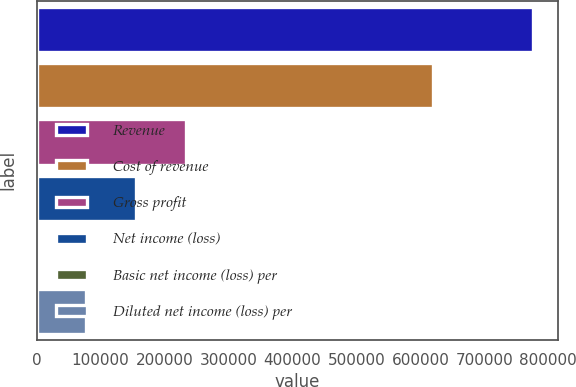<chart> <loc_0><loc_0><loc_500><loc_500><bar_chart><fcel>Revenue<fcel>Cost of revenue<fcel>Gross profit<fcel>Net income (loss)<fcel>Basic net income (loss) per<fcel>Diluted net income (loss) per<nl><fcel>776520<fcel>619797<fcel>232956<fcel>155304<fcel>0.19<fcel>77652.2<nl></chart> 